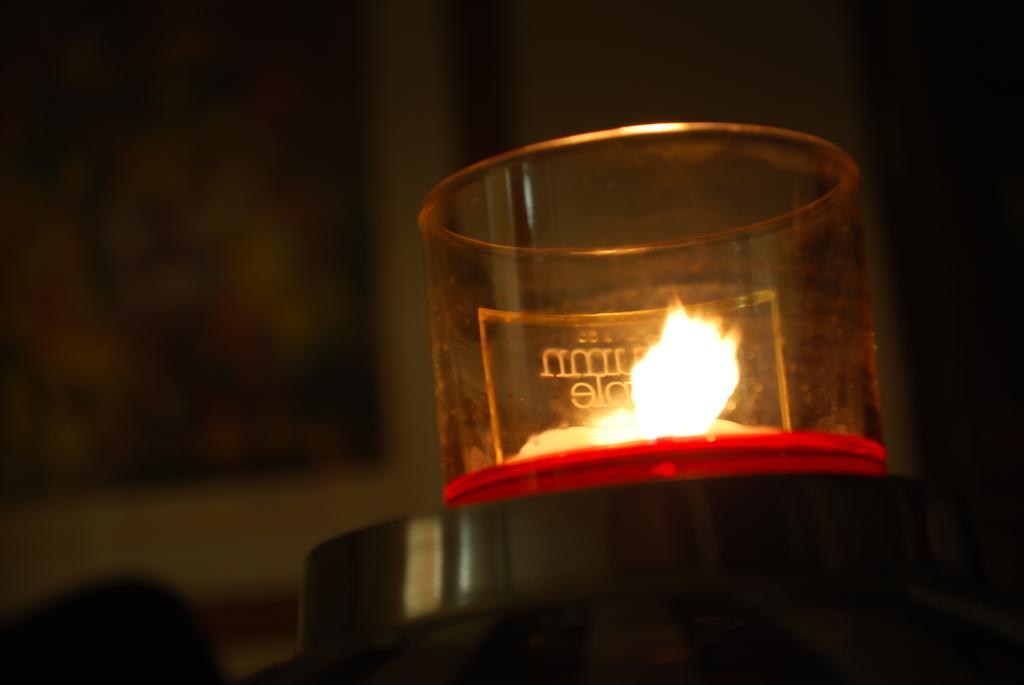In one or two sentences, can you explain what this image depicts? In this image, we can see an object with a glass container and some flame in it. We can also see the blurred background. 